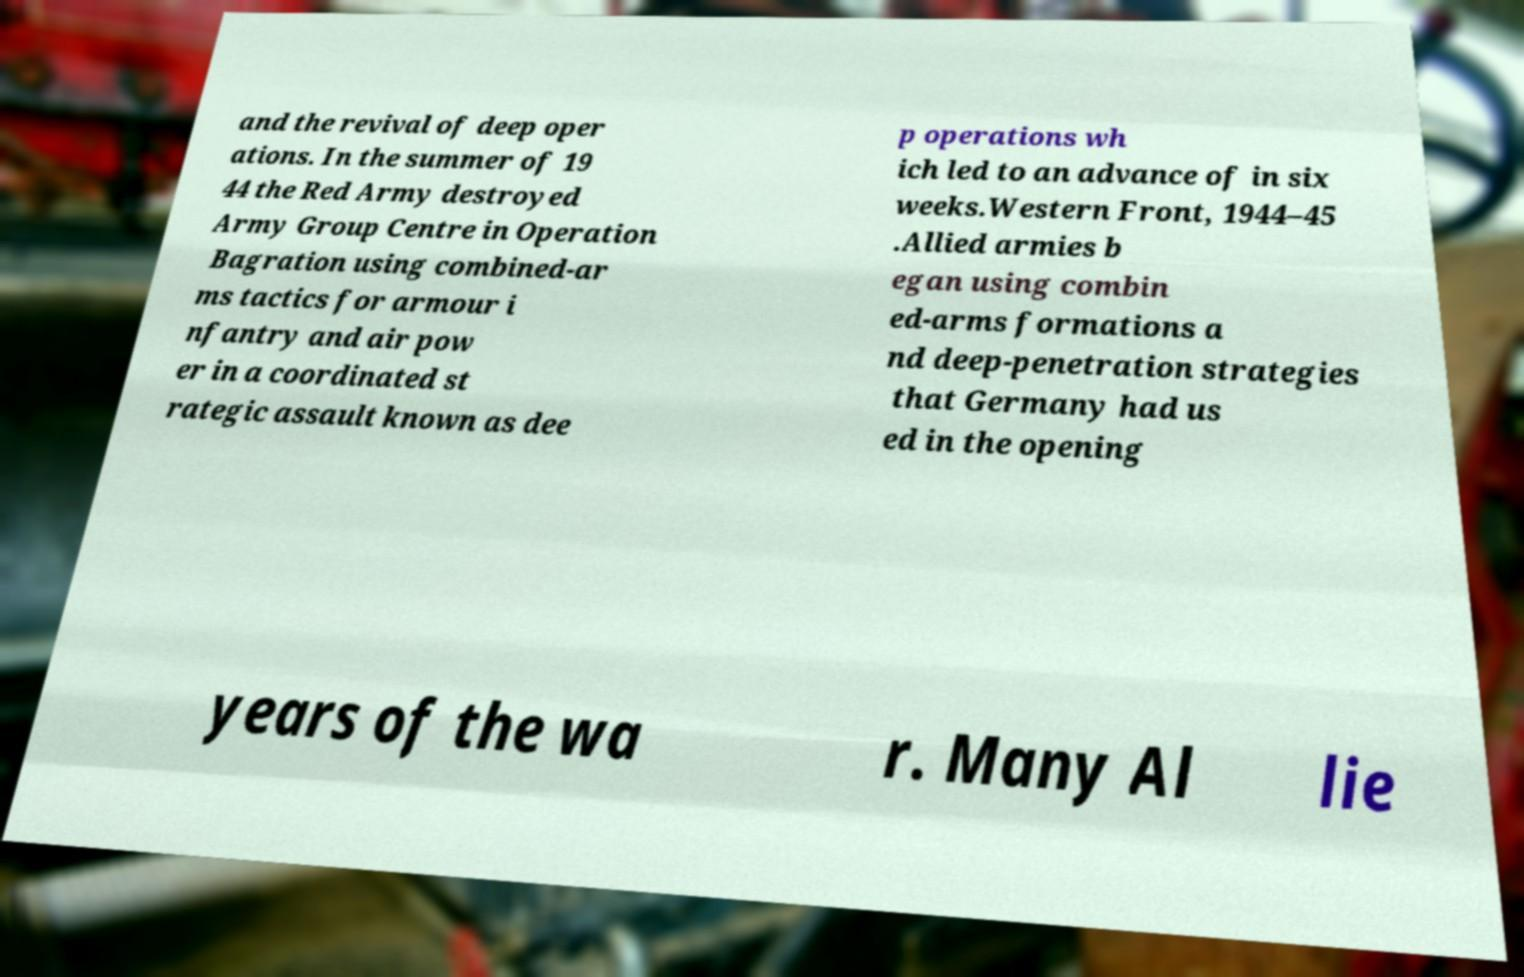Could you assist in decoding the text presented in this image and type it out clearly? and the revival of deep oper ations. In the summer of 19 44 the Red Army destroyed Army Group Centre in Operation Bagration using combined-ar ms tactics for armour i nfantry and air pow er in a coordinated st rategic assault known as dee p operations wh ich led to an advance of in six weeks.Western Front, 1944–45 .Allied armies b egan using combin ed-arms formations a nd deep-penetration strategies that Germany had us ed in the opening years of the wa r. Many Al lie 